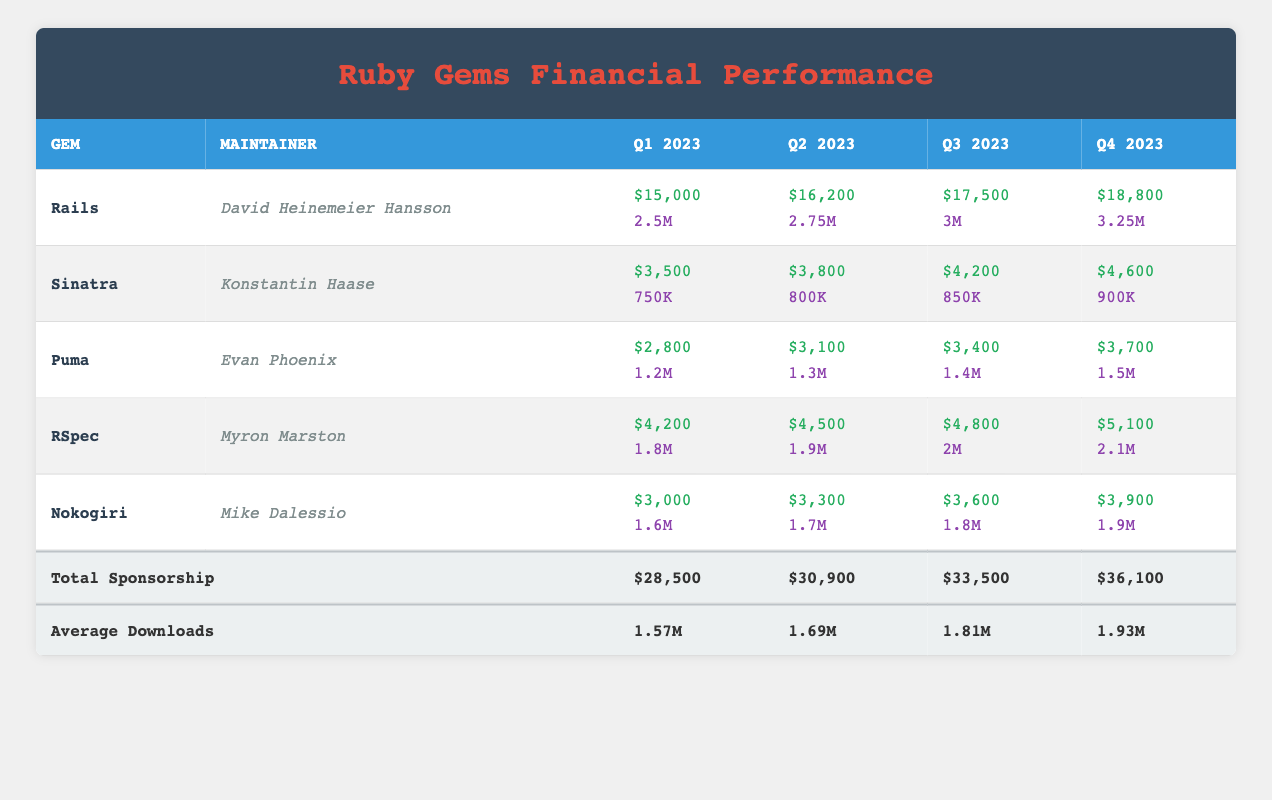What is the sponsorship income for Sinatra in Q2 2023? From the row corresponding to the Sinatra gem, I can see that the value for the Q2 2023 sponsorship income is listed as $3,800.
Answer: $3,800 Which gem had the highest sponsor income in Q4 2023? Checking the sponsorship income for each gem in Q4 2023, Rails has the highest income listed at $18,800, compared to other gems.
Answer: Rails What is the total sponsorship income across all quarters? The table shows a row for total sponsorship at the bottom, which adds up the quarterly sponsorship incomes: $28,500 + $30,900 + $33,500 + $36,100 = $129,000.
Answer: $129,000 How much did RSpec earn from Q1 to Q4 2023? To find the total for RSpec, I add the quarterly sponsorship income: $4,200 (Q1) + $4,500 (Q2) + $4,800 (Q3) + $5,100 (Q4) = $18,600.
Answer: $18,600 Did Nokogiri's sponsorship income increase every quarter in 2023? Checking each quarterly income for Nokogiri, the values are $3,000 (Q1), $3,300 (Q2), $3,600 (Q3), and $3,900 (Q4). All values increase from one quarter to the next.
Answer: Yes What were average downloads across all quarters? From the total row for average downloads, the provided values for each quarter are: Q1 = 1.57M, Q2 = 1.69M, Q3 = 1.81M, and Q4 = 1.93M. The average remains consistent as provided.
Answer: 1.57M, 1.69M, 1.81M, 1.93M Which maintainer received the least sponsorship income in Q1 2023? Review the sponsorship incomes for all gems in Q1. The lowest value is seen for Puma at $2,800 in Q1 2023, with others being higher.
Answer: Evan Phoenix What is the percentage increase in downloads for Rails from Q1 to Q4? First, find the value for downloads in Q1 ($2,500,000) and in Q4 ($3,250,000). The increase is calculated as: ((3,250,000 - 2,500,000) / 2,500,000) * 100 = 30%.
Answer: 30% How does the total sponsorship for Q3 compare to Q2? The total sponsorship for Q3 (which is $33,500) is then compared with Q2 ($30,900). The difference is $33,500 - $30,900 = $2,600. Thus, Q3 has more sponsorship than Q2.
Answer: More by $2,600 